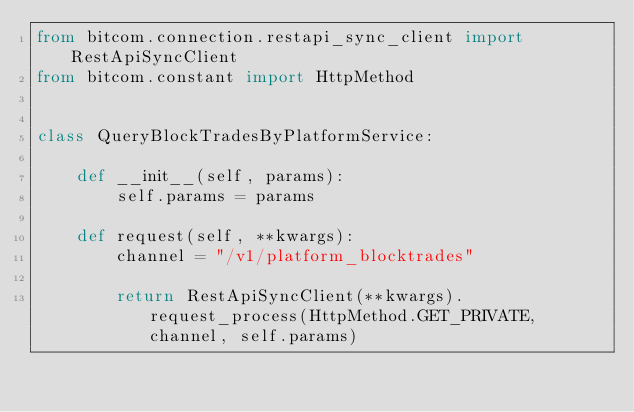<code> <loc_0><loc_0><loc_500><loc_500><_Python_>from bitcom.connection.restapi_sync_client import RestApiSyncClient
from bitcom.constant import HttpMethod


class QueryBlockTradesByPlatformService:

    def __init__(self, params):
        self.params = params

    def request(self, **kwargs):
        channel = "/v1/platform_blocktrades"

        return RestApiSyncClient(**kwargs).request_process(HttpMethod.GET_PRIVATE, channel, self.params)</code> 